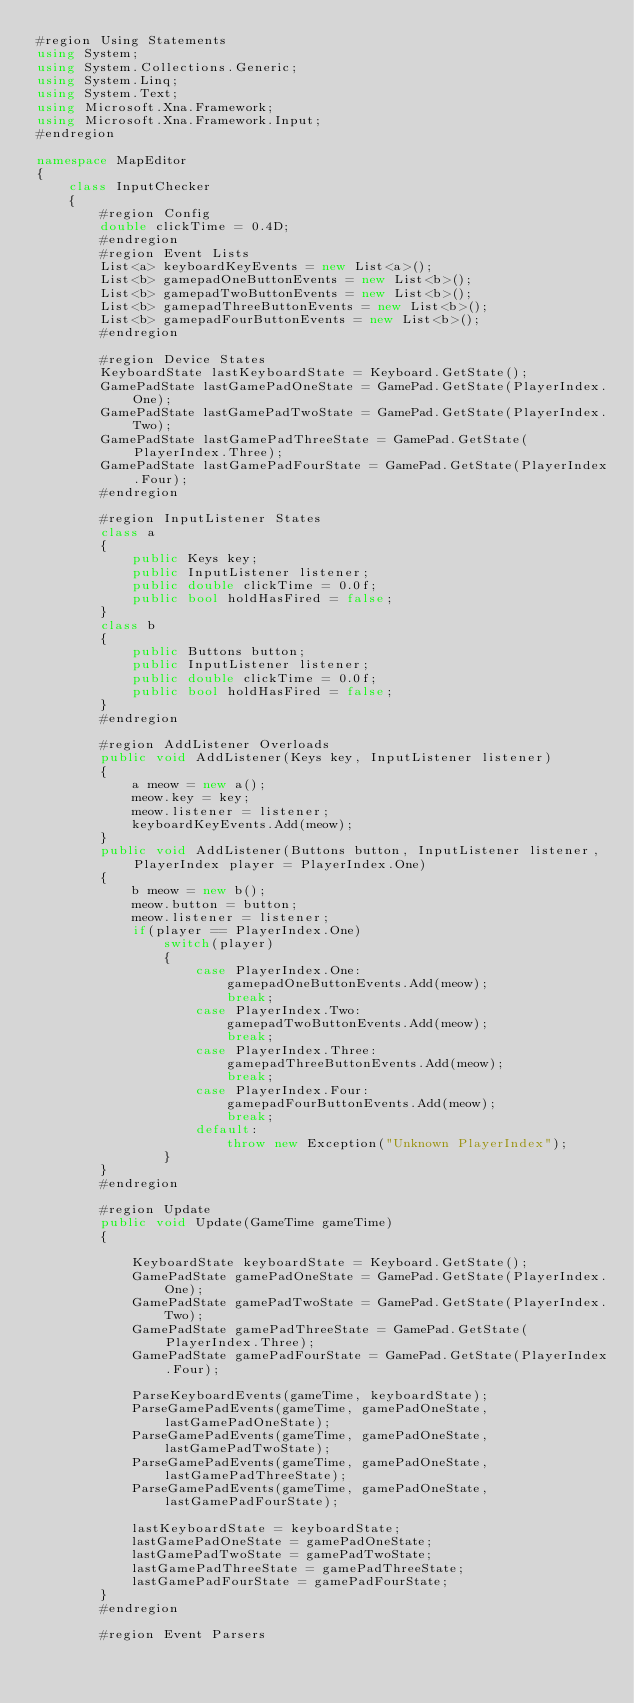<code> <loc_0><loc_0><loc_500><loc_500><_C#_>#region Using Statements
using System;
using System.Collections.Generic;
using System.Linq;
using System.Text;
using Microsoft.Xna.Framework;
using Microsoft.Xna.Framework.Input;
#endregion

namespace MapEditor
{
    class InputChecker
    {
        #region Config
        double clickTime = 0.4D;
        #endregion
        #region Event Lists
        List<a> keyboardKeyEvents = new List<a>();
        List<b> gamepadOneButtonEvents = new List<b>();
        List<b> gamepadTwoButtonEvents = new List<b>();
        List<b> gamepadThreeButtonEvents = new List<b>();
        List<b> gamepadFourButtonEvents = new List<b>();
        #endregion

        #region Device States
        KeyboardState lastKeyboardState = Keyboard.GetState();
        GamePadState lastGamePadOneState = GamePad.GetState(PlayerIndex.One);
        GamePadState lastGamePadTwoState = GamePad.GetState(PlayerIndex.Two);
        GamePadState lastGamePadThreeState = GamePad.GetState(PlayerIndex.Three);
        GamePadState lastGamePadFourState = GamePad.GetState(PlayerIndex.Four);
        #endregion

        #region InputListener States
        class a
        {
            public Keys key;
            public InputListener listener;
            public double clickTime = 0.0f;
            public bool holdHasFired = false;
        }
        class b
        {
            public Buttons button;
            public InputListener listener;
            public double clickTime = 0.0f;
            public bool holdHasFired = false;
        }
        #endregion

        #region AddListener Overloads
        public void AddListener(Keys key, InputListener listener)
        {
            a meow = new a();
            meow.key = key;
            meow.listener = listener;
            keyboardKeyEvents.Add(meow);
        }
        public void AddListener(Buttons button, InputListener listener, PlayerIndex player = PlayerIndex.One)
        {
            b meow = new b();
            meow.button = button;
            meow.listener = listener;
            if(player == PlayerIndex.One)
                switch(player)
                {
                    case PlayerIndex.One:
                        gamepadOneButtonEvents.Add(meow);
                        break;
                    case PlayerIndex.Two:
                        gamepadTwoButtonEvents.Add(meow);
                        break;
                    case PlayerIndex.Three:
                        gamepadThreeButtonEvents.Add(meow);
                        break;
                    case PlayerIndex.Four:
                        gamepadFourButtonEvents.Add(meow);
                        break;
                    default:
                        throw new Exception("Unknown PlayerIndex");
                }
        }
        #endregion

        #region Update
        public void Update(GameTime gameTime)
        {

            KeyboardState keyboardState = Keyboard.GetState();
            GamePadState gamePadOneState = GamePad.GetState(PlayerIndex.One);
            GamePadState gamePadTwoState = GamePad.GetState(PlayerIndex.Two);
            GamePadState gamePadThreeState = GamePad.GetState(PlayerIndex.Three);
            GamePadState gamePadFourState = GamePad.GetState(PlayerIndex.Four);

            ParseKeyboardEvents(gameTime, keyboardState);
            ParseGamePadEvents(gameTime, gamePadOneState, lastGamePadOneState);
            ParseGamePadEvents(gameTime, gamePadOneState, lastGamePadTwoState);
            ParseGamePadEvents(gameTime, gamePadOneState, lastGamePadThreeState);
            ParseGamePadEvents(gameTime, gamePadOneState, lastGamePadFourState);

            lastKeyboardState = keyboardState;
            lastGamePadOneState = gamePadOneState;
            lastGamePadTwoState = gamePadTwoState;
            lastGamePadThreeState = gamePadThreeState;
            lastGamePadFourState = gamePadFourState;
        }
        #endregion

        #region Event Parsers</code> 